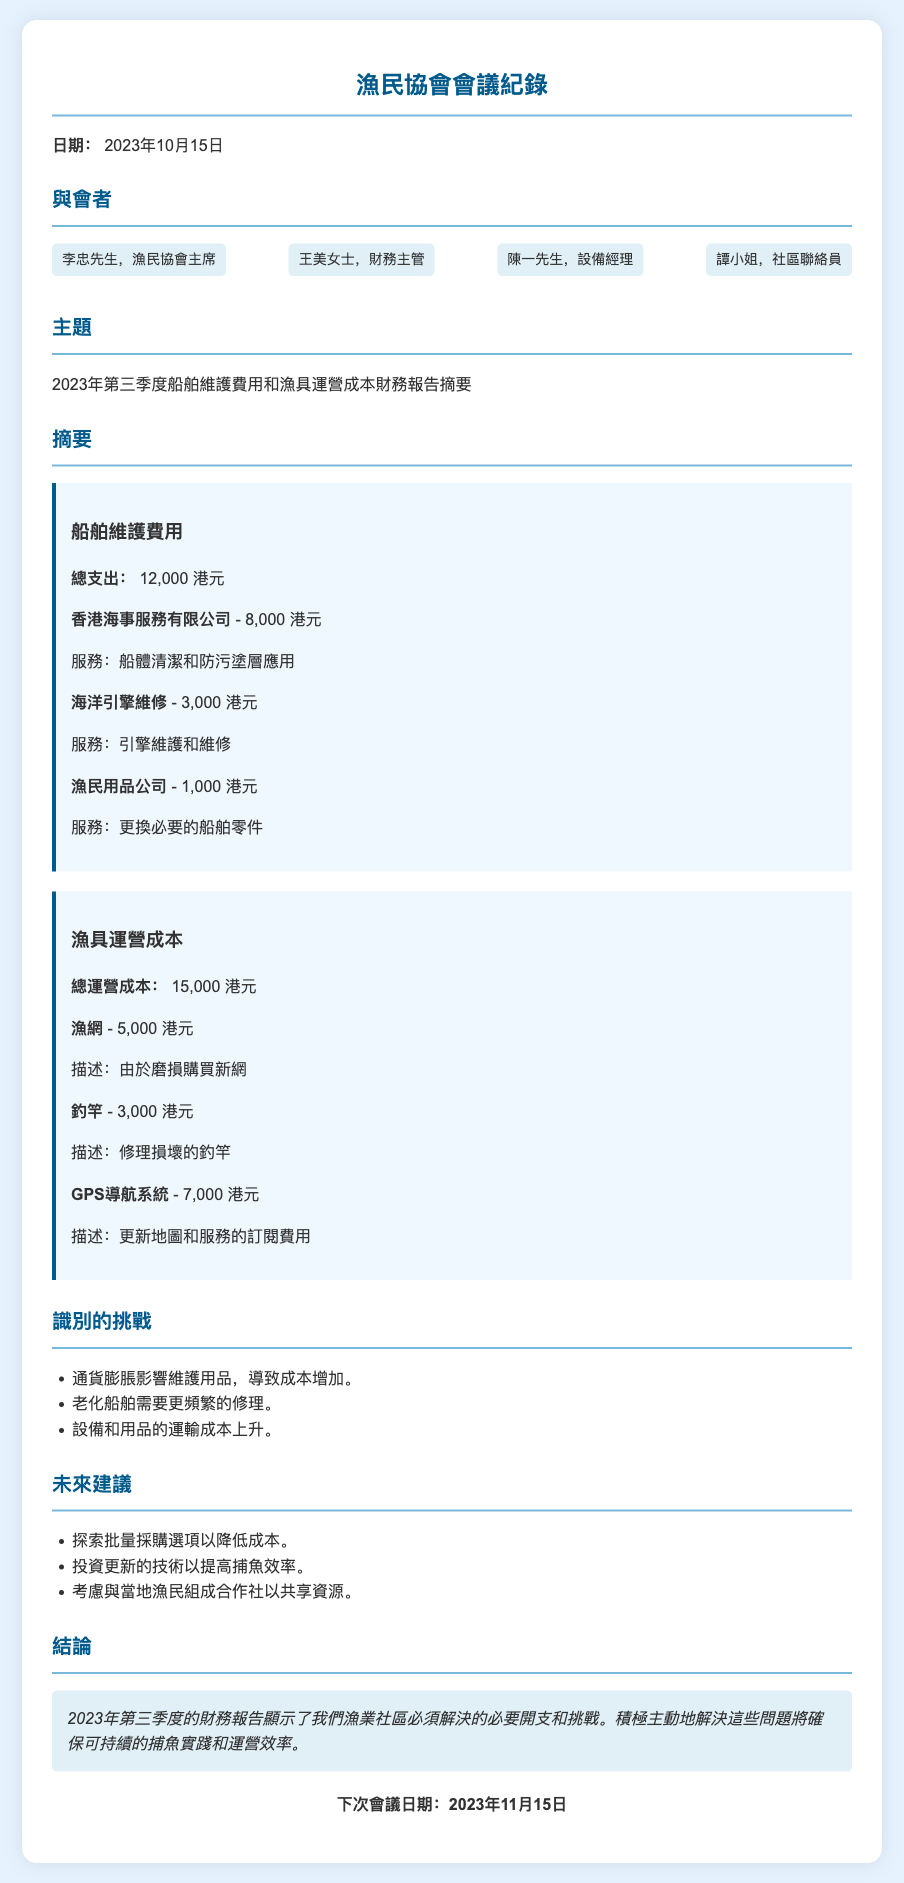what is the total boat maintenance expense? The total boat maintenance expense is explicitly stated in the document.
Answer: 12,000 港元 who is the financial officer present in the meeting? The document lists attendees and their roles; the financial officer is one of them.
Answer: 王美女士 what is the total operational cost for fishing equipment? The operational cost for fishing equipment is specifically provided in the document.
Answer: 15,000 港元 which company provided the hull cleaning service? One of the cost items mentions the company that provided this service.
Answer: 香港海事服務有限公司 what are two identified challenges noted in the report? The document lists challenges, and I can extract any two of them for the answer.
Answer: 通貨膨脹影響維護用品，老化船舶需要更頻繁的修理 how much did they spend on updating the GPS navigation system? The document provides a specific item and amount for this service.
Answer: 7,000 港元 when is the next meeting scheduled? The conclusion section includes the date of the next meeting.
Answer: 2023年11月15日 what is one future recommendation mentioned? The document outlines future recommendations; any single one can serve as an answer.
Answer: 探索批量採購選項以降低成本 how many attendees are listed in the meeting minutes? The attendees section gives a count of the individuals present.
Answer: 4 